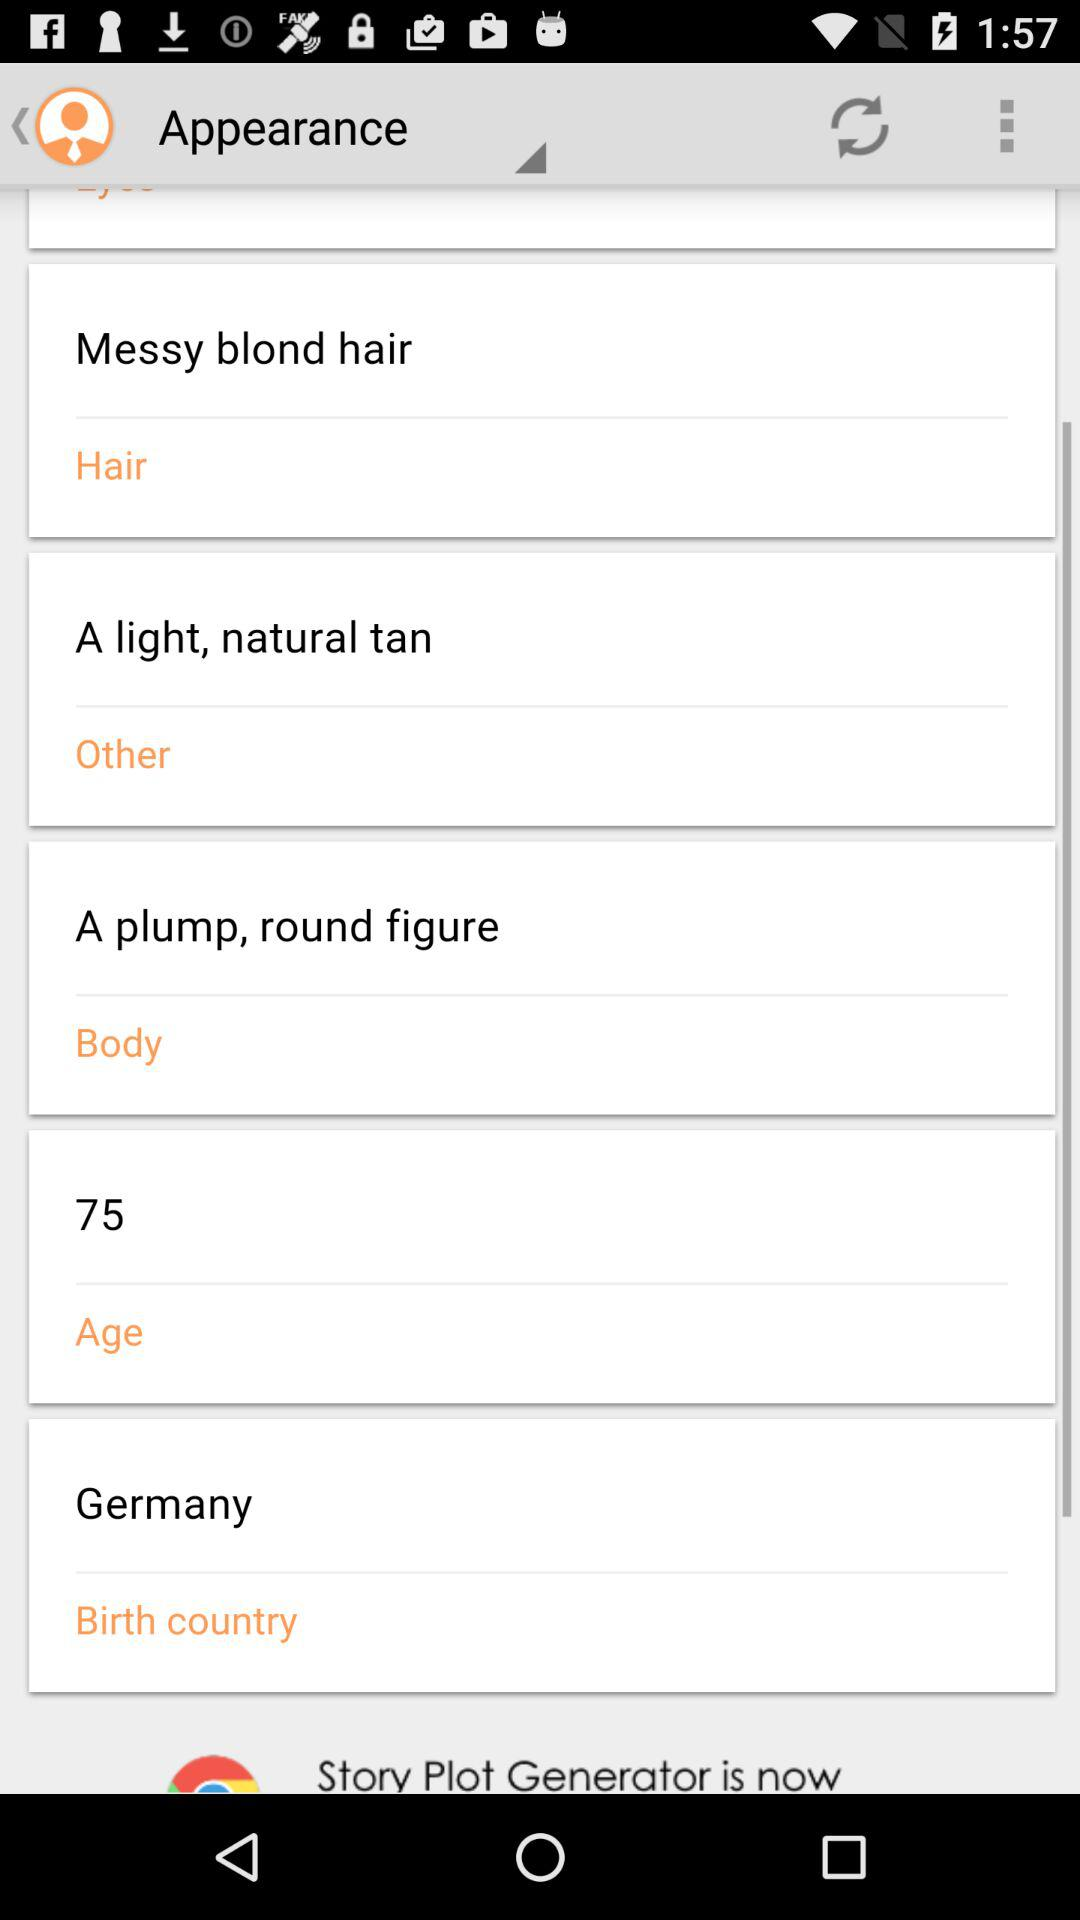When is the user's birthday?
When the provided information is insufficient, respond with <no answer>. <no answer> 